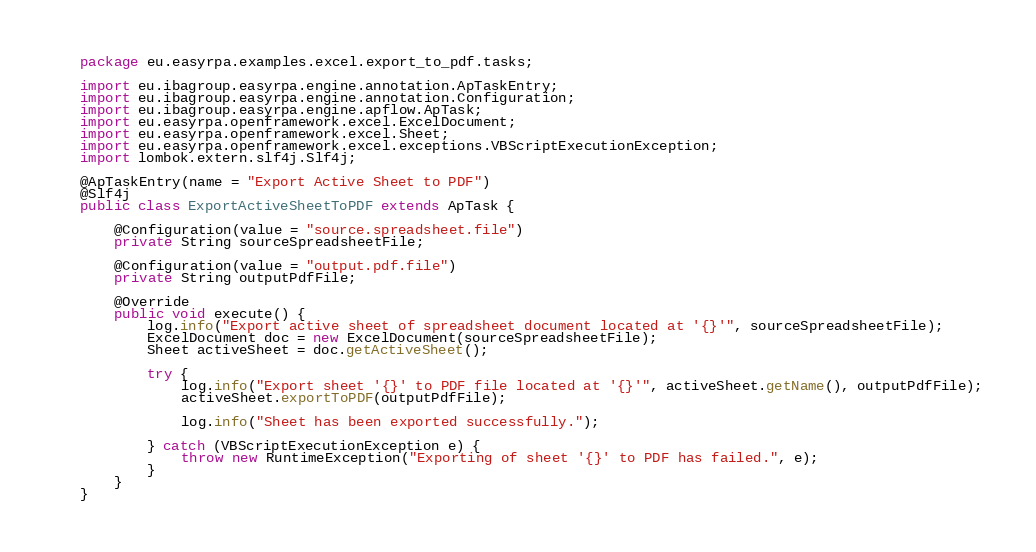Convert code to text. <code><loc_0><loc_0><loc_500><loc_500><_Java_>package eu.easyrpa.examples.excel.export_to_pdf.tasks;

import eu.ibagroup.easyrpa.engine.annotation.ApTaskEntry;
import eu.ibagroup.easyrpa.engine.annotation.Configuration;
import eu.ibagroup.easyrpa.engine.apflow.ApTask;
import eu.easyrpa.openframework.excel.ExcelDocument;
import eu.easyrpa.openframework.excel.Sheet;
import eu.easyrpa.openframework.excel.exceptions.VBScriptExecutionException;
import lombok.extern.slf4j.Slf4j;

@ApTaskEntry(name = "Export Active Sheet to PDF")
@Slf4j
public class ExportActiveSheetToPDF extends ApTask {

    @Configuration(value = "source.spreadsheet.file")
    private String sourceSpreadsheetFile;

    @Configuration(value = "output.pdf.file")
    private String outputPdfFile;

    @Override
    public void execute() {
        log.info("Export active sheet of spreadsheet document located at '{}'", sourceSpreadsheetFile);
        ExcelDocument doc = new ExcelDocument(sourceSpreadsheetFile);
        Sheet activeSheet = doc.getActiveSheet();

        try {
            log.info("Export sheet '{}' to PDF file located at '{}'", activeSheet.getName(), outputPdfFile);
            activeSheet.exportToPDF(outputPdfFile);

            log.info("Sheet has been exported successfully.");

        } catch (VBScriptExecutionException e) {
            throw new RuntimeException("Exporting of sheet '{}' to PDF has failed.", e);
        }
    }
}
</code> 